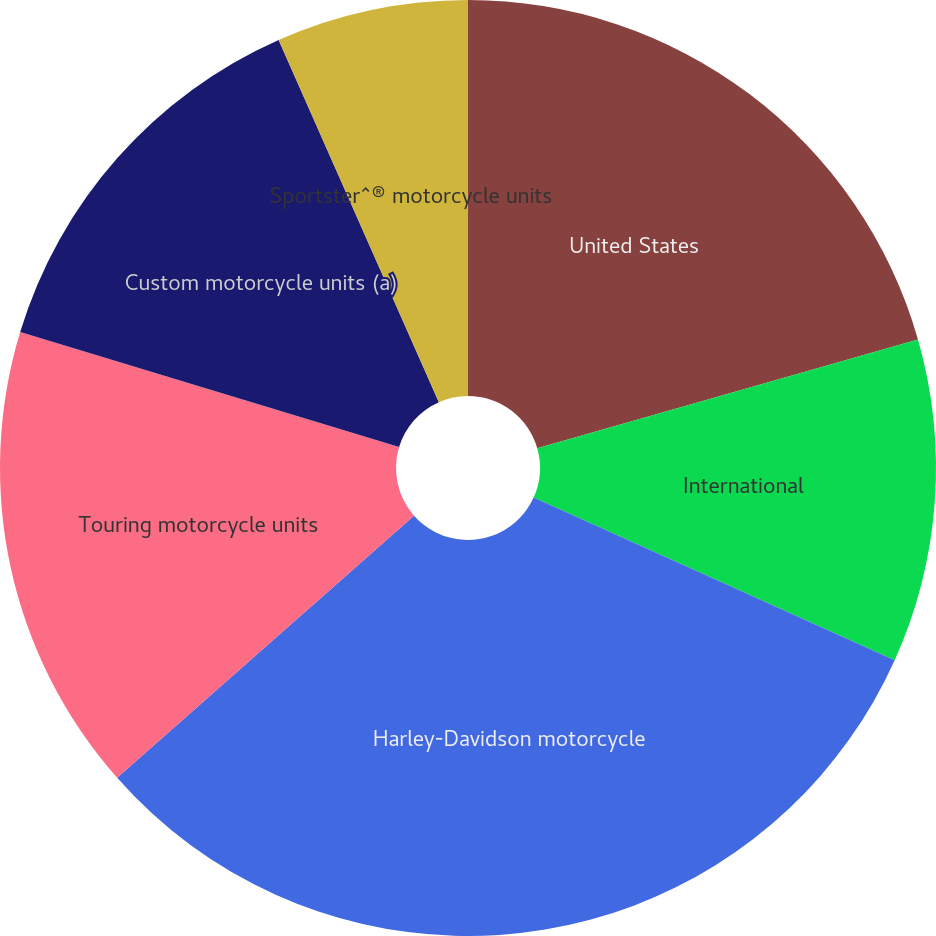<chart> <loc_0><loc_0><loc_500><loc_500><pie_chart><fcel>United States<fcel>International<fcel>Harley-Davidson motorcycle<fcel>Touring motorcycle units<fcel>Custom motorcycle units (a)<fcel>Sportster^® motorcycle units<nl><fcel>20.57%<fcel>11.17%<fcel>31.75%<fcel>16.2%<fcel>13.68%<fcel>6.63%<nl></chart> 